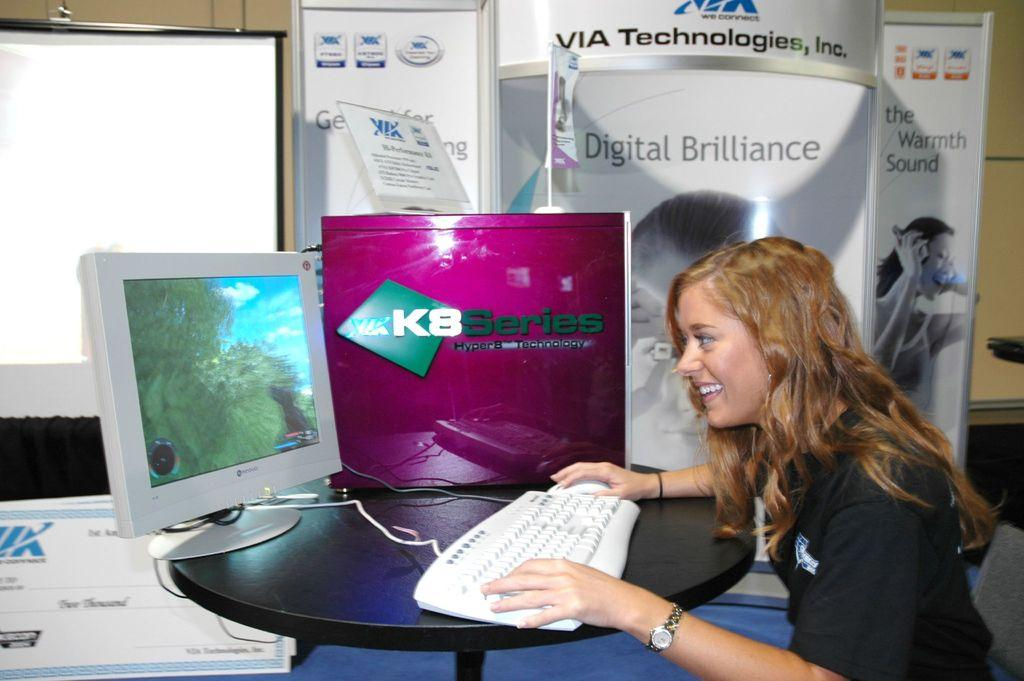<image>
Offer a succinct explanation of the picture presented. a woman sitting next to a sign that says 'digital brilliance' 